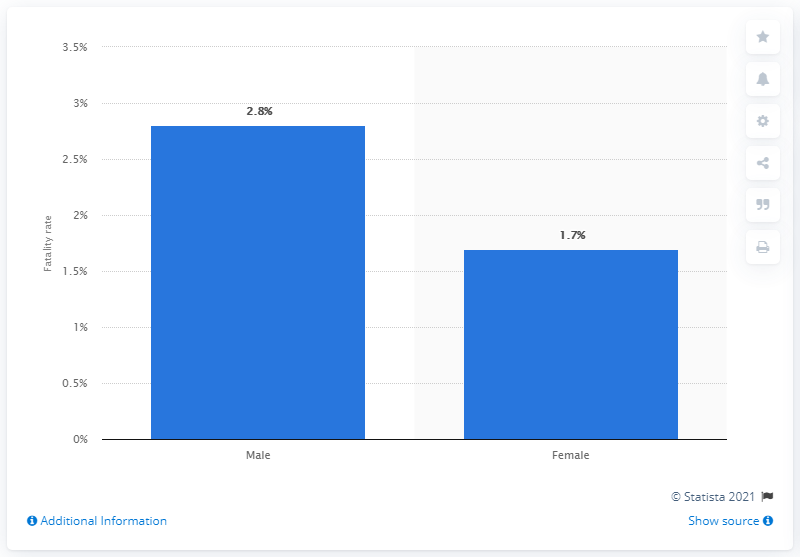Highlight a few significant elements in this photo. As of February 11, 2020, the fatality rate of COVID-19 among male patients in China was 2.8. 